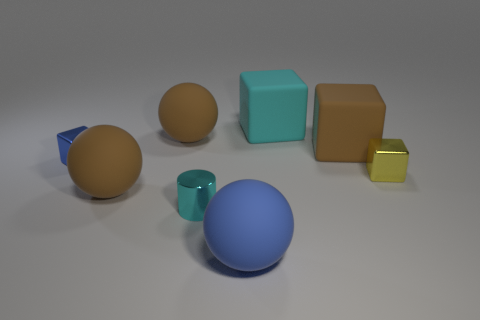What number of blue shiny blocks are behind the small blue shiny block?
Make the answer very short. 0. Do the cube that is left of the big cyan matte thing and the big cyan thing have the same material?
Keep it short and to the point. No. What number of blue shiny objects are the same shape as the large blue matte thing?
Ensure brevity in your answer.  0. What number of tiny objects are either shiny blocks or gray metallic cubes?
Ensure brevity in your answer.  2. There is a big matte sphere behind the blue cube; is its color the same as the cylinder?
Give a very brief answer. No. Does the tiny shiny block that is to the right of the large cyan rubber cube have the same color as the ball that is behind the blue metal block?
Provide a short and direct response. No. Is there a big red block made of the same material as the big blue ball?
Offer a terse response. No. What number of red things are either matte spheres or big things?
Your answer should be very brief. 0. Is the number of brown blocks that are in front of the large cyan rubber cube greater than the number of large gray matte things?
Your response must be concise. Yes. Do the yellow thing and the cyan cube have the same size?
Ensure brevity in your answer.  No. 